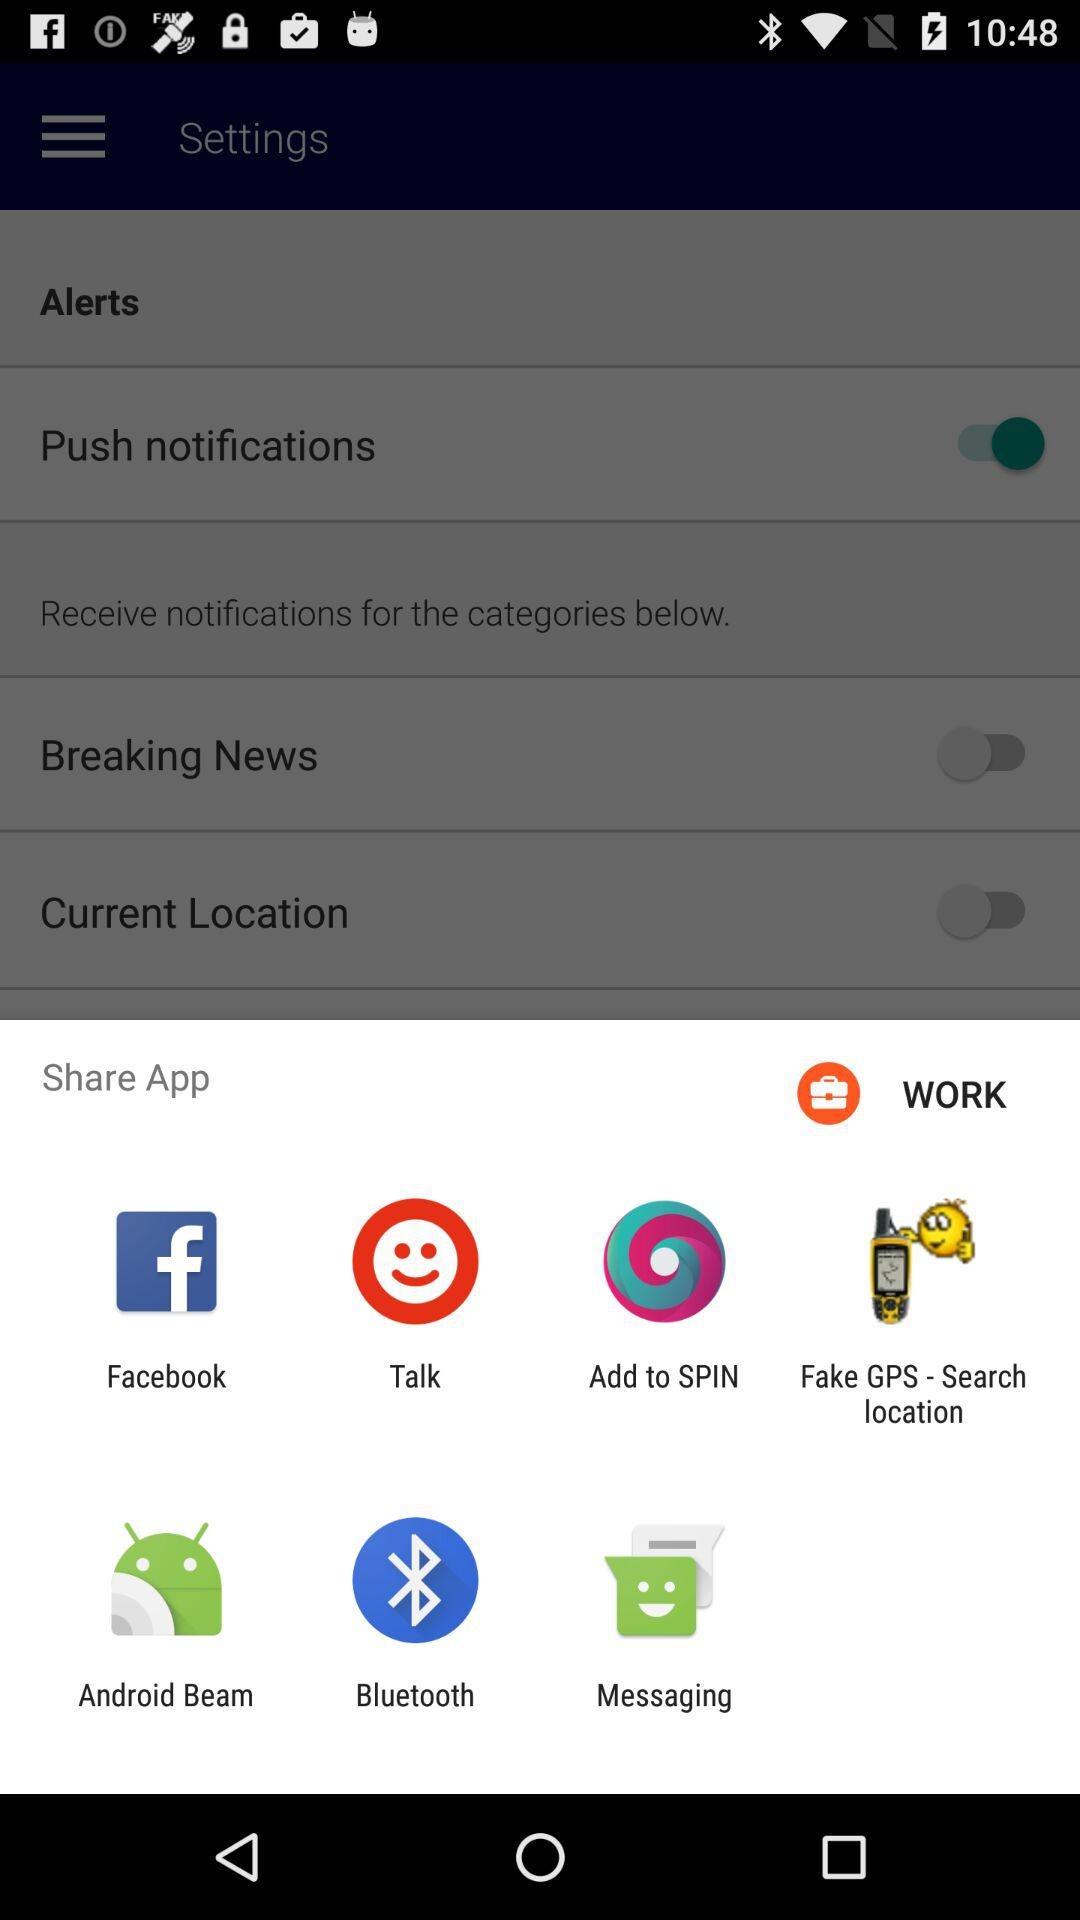Through what application can be shared? You can share with "Facebook", "Talk", "Add to SPIN", "Fake GPS - Search location", "Android Beam", "Bluetooth" and Messaging. 